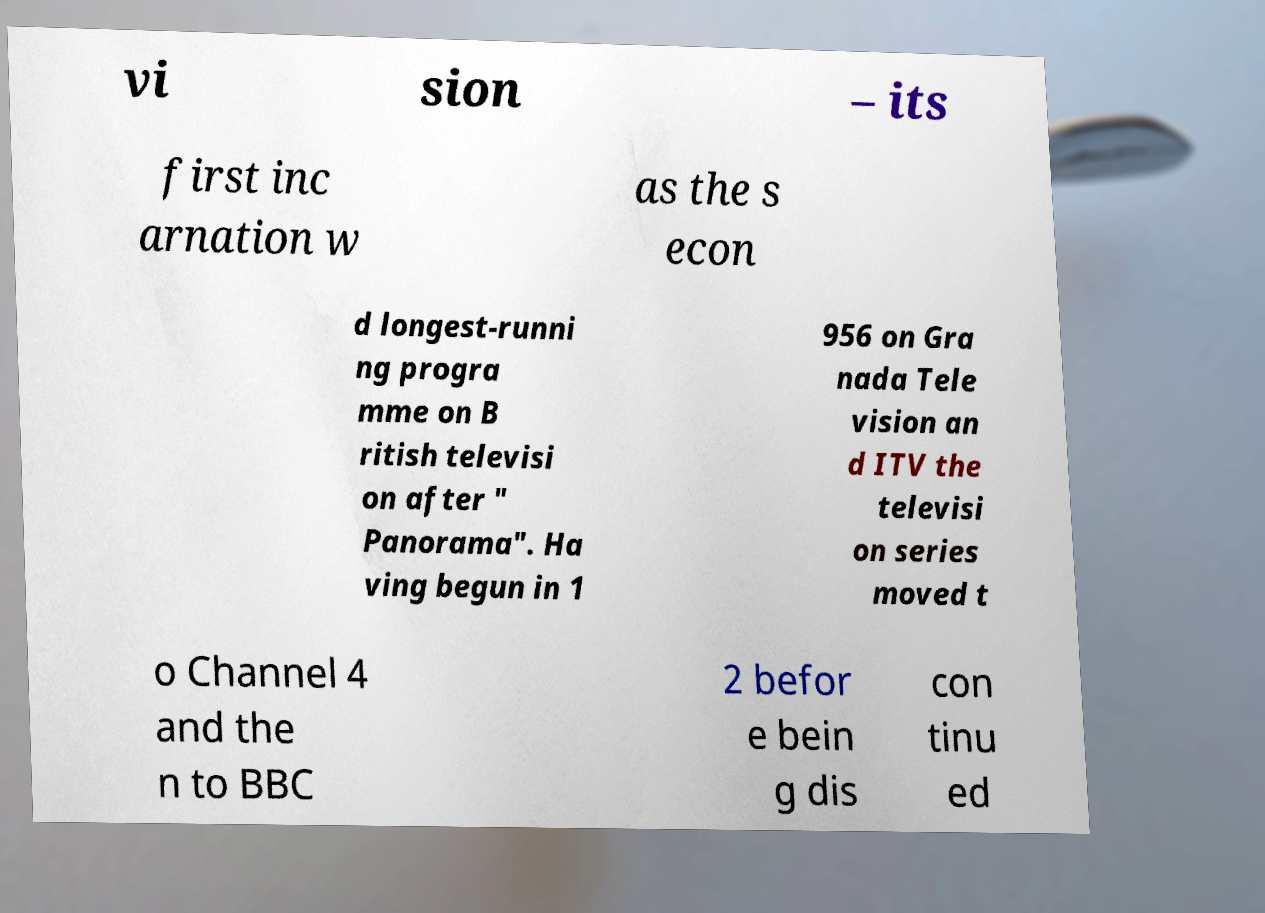Could you extract and type out the text from this image? vi sion – its first inc arnation w as the s econ d longest-runni ng progra mme on B ritish televisi on after " Panorama". Ha ving begun in 1 956 on Gra nada Tele vision an d ITV the televisi on series moved t o Channel 4 and the n to BBC 2 befor e bein g dis con tinu ed 